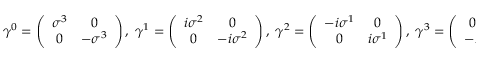<formula> <loc_0><loc_0><loc_500><loc_500>\gamma ^ { 0 } = \left ( \begin{array} { c c } { { \sigma ^ { 3 } } } & { 0 } \\ { 0 } & { { - \sigma ^ { 3 } } } \end{array} \right ) , \, \gamma ^ { 1 } = \left ( \begin{array} { c c } { { i \sigma ^ { 2 } } } & { 0 } \\ { 0 } & { { - i \sigma ^ { 2 } } } \end{array} \right ) , \, \gamma ^ { 2 } = \left ( \begin{array} { c c } { { - i \sigma ^ { 1 } } } & { 0 } \\ { 0 } & { { i \sigma ^ { 1 } } } \end{array} \right ) , \, \gamma ^ { 3 } = \left ( \begin{array} { c c } { 0 } & { I } \\ { - I } & { 0 } \end{array} \right ) \, .</formula> 